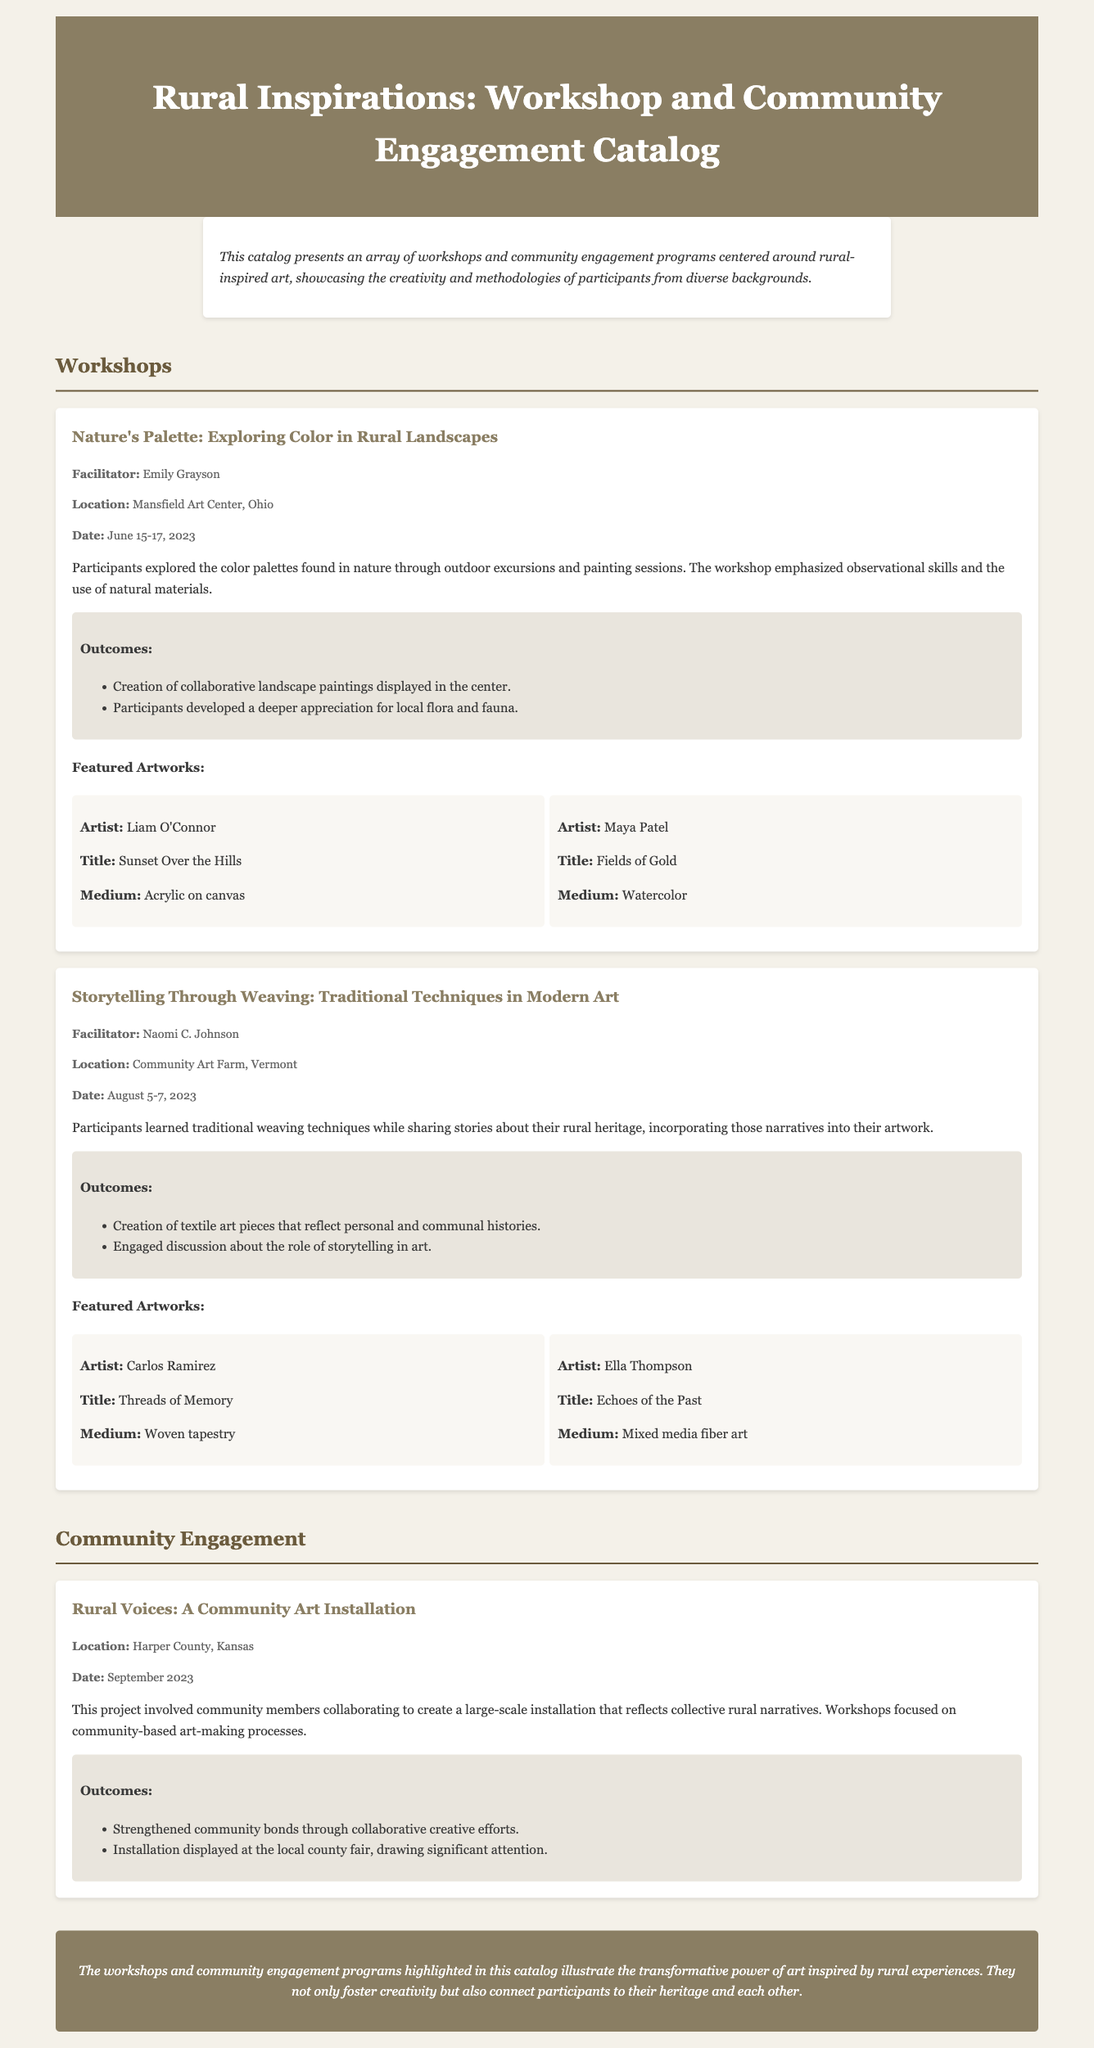What is the title of the catalog? The title of the catalog is presented in the header section of the document.
Answer: Rural Inspirations: Workshop and Community Engagement Catalog Who facilitated the workshop titled "Nature's Palette"? The facilitator's name is provided in the workshop details.
Answer: Emily Grayson What medium was used by Maya Patel for her artwork? The medium is specified in the featured artworks section for each artist.
Answer: Watercolor When did the "Storytelling Through Weaving" workshop take place? The date of the workshop is listed in the workshop details section.
Answer: August 5-7, 2023 What was one outcome of the "Rural Voices" community art installation? The outcomes are listed under the project details after describing the engagement.
Answer: Strengthened community bonds through collaborative creative efforts How many featured artworks are mentioned in the "Nature's Palette" workshop? The number of artworks is inferred from the displayed artworks section of the workshop.
Answer: Two What is the location of the "Rural Voices" project? The location is specified in the project details section of the community engagement.
Answer: Harper County, Kansas What concept did participants explore in the "Nature's Palette" workshop? The concept is described in the brief overview of the workshop.
Answer: Color palettes found in nature 